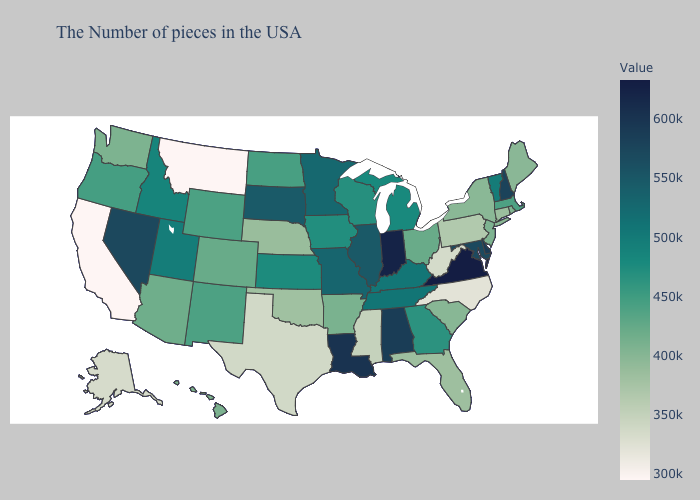Among the states that border California , which have the highest value?
Give a very brief answer. Nevada. Among the states that border Kansas , does Missouri have the lowest value?
Give a very brief answer. No. Among the states that border Massachusetts , which have the lowest value?
Short answer required. Connecticut. Which states have the lowest value in the West?
Answer briefly. Montana, California. Which states have the lowest value in the USA?
Answer briefly. Montana, California. Does California have the lowest value in the West?
Give a very brief answer. Yes. Does North Dakota have the lowest value in the MidWest?
Short answer required. No. 